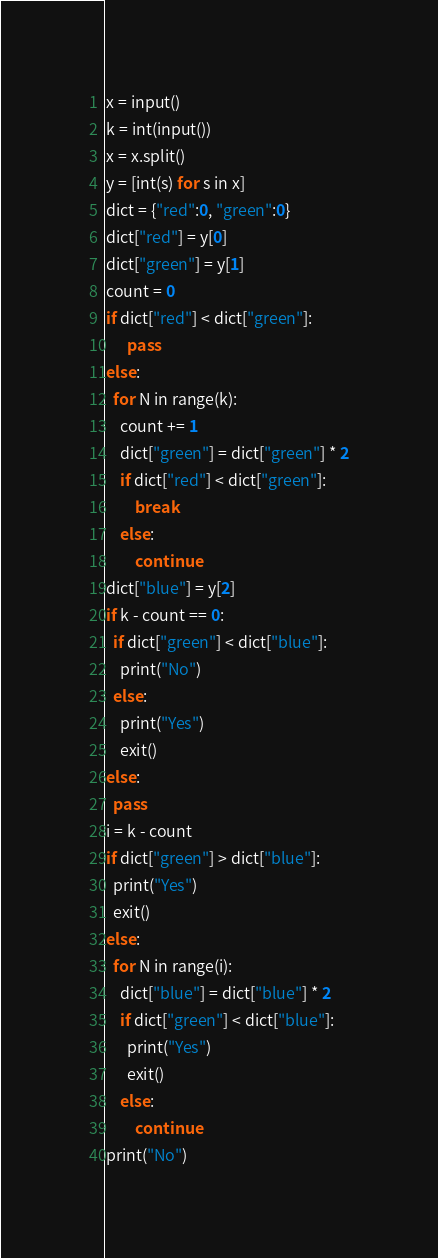<code> <loc_0><loc_0><loc_500><loc_500><_Python_>x = input()
k = int(input())
x = x.split()
y = [int(s) for s in x]
dict = {"red":0, "green":0}
dict["red"] = y[0]
dict["green"] = y[1]
count = 0
if dict["red"] < dict["green"]:
      pass
else:
  for N in range(k):
    count += 1
    dict["green"] = dict["green"] * 2
    if dict["red"] < dict["green"]:
        break
    else:
        continue
dict["blue"] = y[2]
if k - count == 0:
  if dict["green"] < dict["blue"]:
    print("No")
  else:
    print("Yes")
    exit()
else:
  pass
i = k - count
if dict["green"] > dict["blue"]:
  print("Yes")
  exit()
else:
  for N in range(i):
    dict["blue"] = dict["blue"] * 2
    if dict["green"] < dict["blue"]:
      print("Yes")
      exit()
    else:
        continue
print("No")</code> 